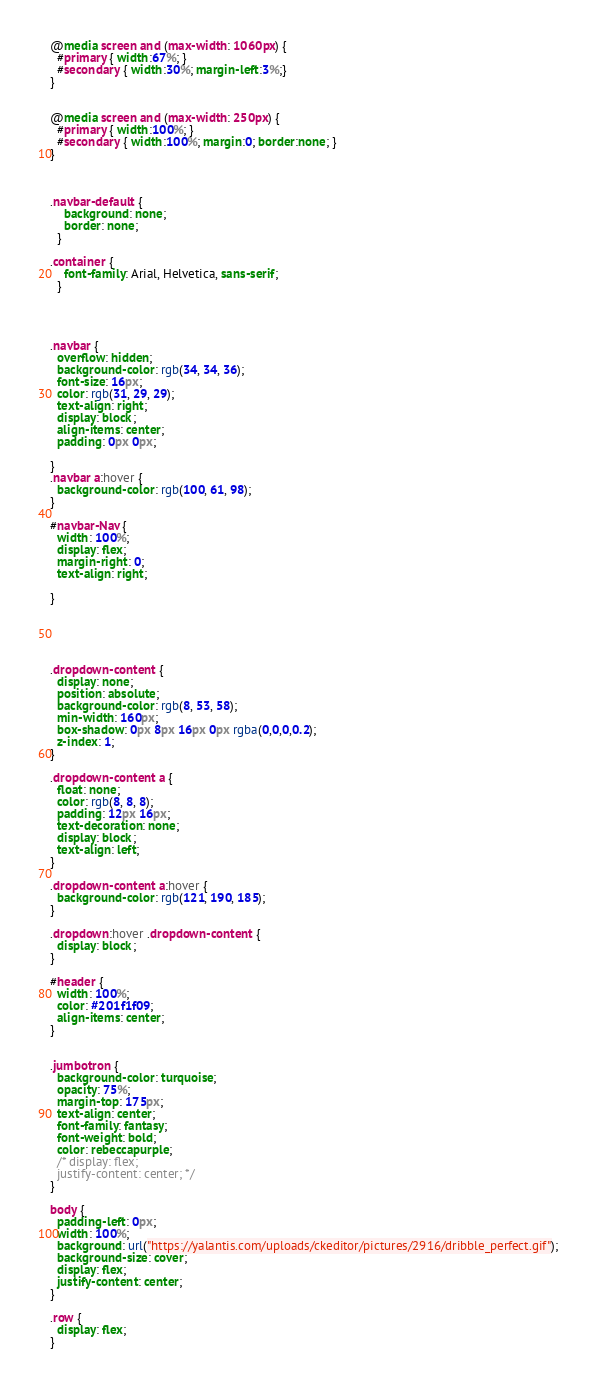<code> <loc_0><loc_0><loc_500><loc_500><_CSS_>@media screen and (max-width: 1060px) {
  #primary { width:67%; }
  #secondary { width:30%; margin-left:3%;}  
}


@media screen and (max-width: 250px) {
  #primary { width:100%; }
  #secondary { width:100%; margin:0; border:none; }
}



.navbar-default {
    background: none;
    border: none;
  }

.container {
    font-family: Arial, Helvetica, sans-serif;
  }

  


.navbar {
  overflow: hidden;
  background-color: rgb(34, 34, 36);
  font-size: 16px;
  color: rgb(31, 29, 29);
  text-align: right;
  display: block;
  align-items: center;
  padding: 0px 0px;
  
}
.navbar a:hover {
  background-color: rgb(100, 61, 98);
}

#navbar-Nav{
  width: 100%;
  display: flex;
  margin-right: 0;
  text-align: right;
  
}





.dropdown-content {
  display: none;
  position: absolute;
  background-color: rgb(8, 53, 58);
  min-width: 160px;
  box-shadow: 0px 8px 16px 0px rgba(0,0,0,0.2);
  z-index: 1;
}

.dropdown-content a {
  float: none;
  color: rgb(8, 8, 8);
  padding: 12px 16px;
  text-decoration: none;
  display: block;
  text-align: left;
}

.dropdown-content a:hover {
  background-color: rgb(121, 190, 185);
}

.dropdown:hover .dropdown-content {
  display: block;
}

#header {
  width: 100%;
  color: #201f1f09;
  align-items: center;
}


.jumbotron { 
  background-color: turquoise;
  opacity: 75%;
  margin-top: 175px;
  text-align: center;
  font-family: fantasy; 
  font-weight: bold;
  color: rebeccapurple;
  /* display: flex;
  justify-content: center; */
}

body {
  padding-left: 0px;
  width: 100%;
  background: url("https://yalantis.com/uploads/ckeditor/pictures/2916/dribble_perfect.gif");
  background-size: cover; 
  display: flex;
  justify-content: center;
}

.row {
  display: flex;
}

</code> 